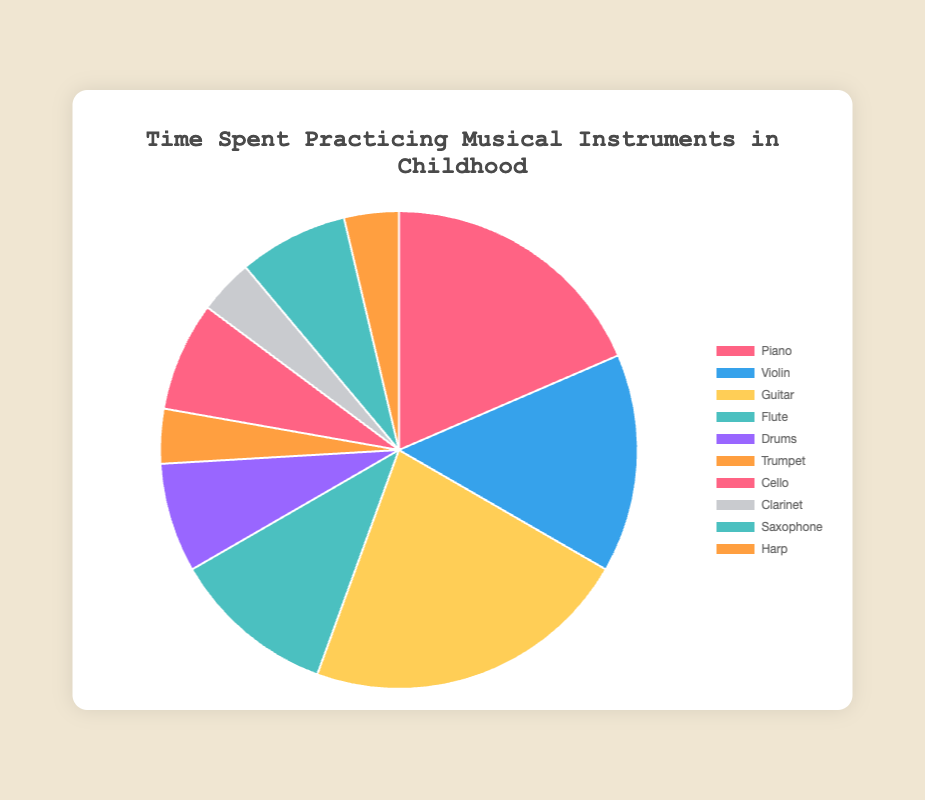Which instrument do you spend the most hours practicing per week? The pie chart shows the hours spent practicing each instrument per week. The instrument with the largest value is the one practiced the most. The highest value in the data set is 6 hours per week for Guitar.
Answer: Guitar What's the total time spent practicing Violin, Drums, and Cello per week? Add the hours spent practicing each of these instruments: Violin (4 hours), Drums (2 hours), and Cello (2 hours). The total is 4 + 2 + 2 = 8 hours per week.
Answer: 8 hours Which instruments do you spend the least hours practicing per week, and how many hours are those? From the pie chart data, the instruments with the least hours (1 hour) are Trumpet, Clarinet, and Harp.
Answer: Trumpet, Clarinet, Harp (1 hour each) Compare the time spent practicing Piano to the time spent practicing the Flute. Which is more, and by how much? The time spent practicing Piano is 5 hours, and for Flute, it is 3 hours. The difference is 5 - 3 = 2 hours. Therefore, more time is spent practicing Piano by 2 hours.
Answer: Piano by 2 hours How many more hours do you practice Guitar compared to the average time spent practicing all instruments? First, find the total hours spent practicing all instruments and then the average time. Total hours = 5 + 4 + 6 + 3 + 2 + 1 + 2 + 1 + 2 + 1 = 27. The average is 27/10 = 2.7 hours. Guitar hours (6) minus the average hours (2.7) gives 6 - 2.7 = 3.3 hours.
Answer: 3.3 hours What proportion of the total practice time is spent on the Violin? The total practice time for all instruments is 27 hours per week. Violin practice time is 4 hours. The proportion is 4/27.
Answer: 4/27 If the practice hours for Guitar and Violin were combined, what would be the new proportion of their combined practice time relative to the total? Combined practice time for Guitar and Violin is 6 + 4 = 10 hours. The proportion of their combined time relative to the total (27 hours) is 10/27.
Answer: 10/27 Identify the two instruments with exactly the same amount of practice time and their corresponding hours per week. The pie chart shows that Drums, Cello, and Saxophone each have 2 hours per week.
Answer: Drums, Cello, Saxophone (2 hours each) Which instrument has a color that stands out the most in the pie chart, and what does it represent? The most visually striking color can vary by viewer, but often the bright red can catch the eye. In this chart, the red color represents Piano.
Answer: Piano 